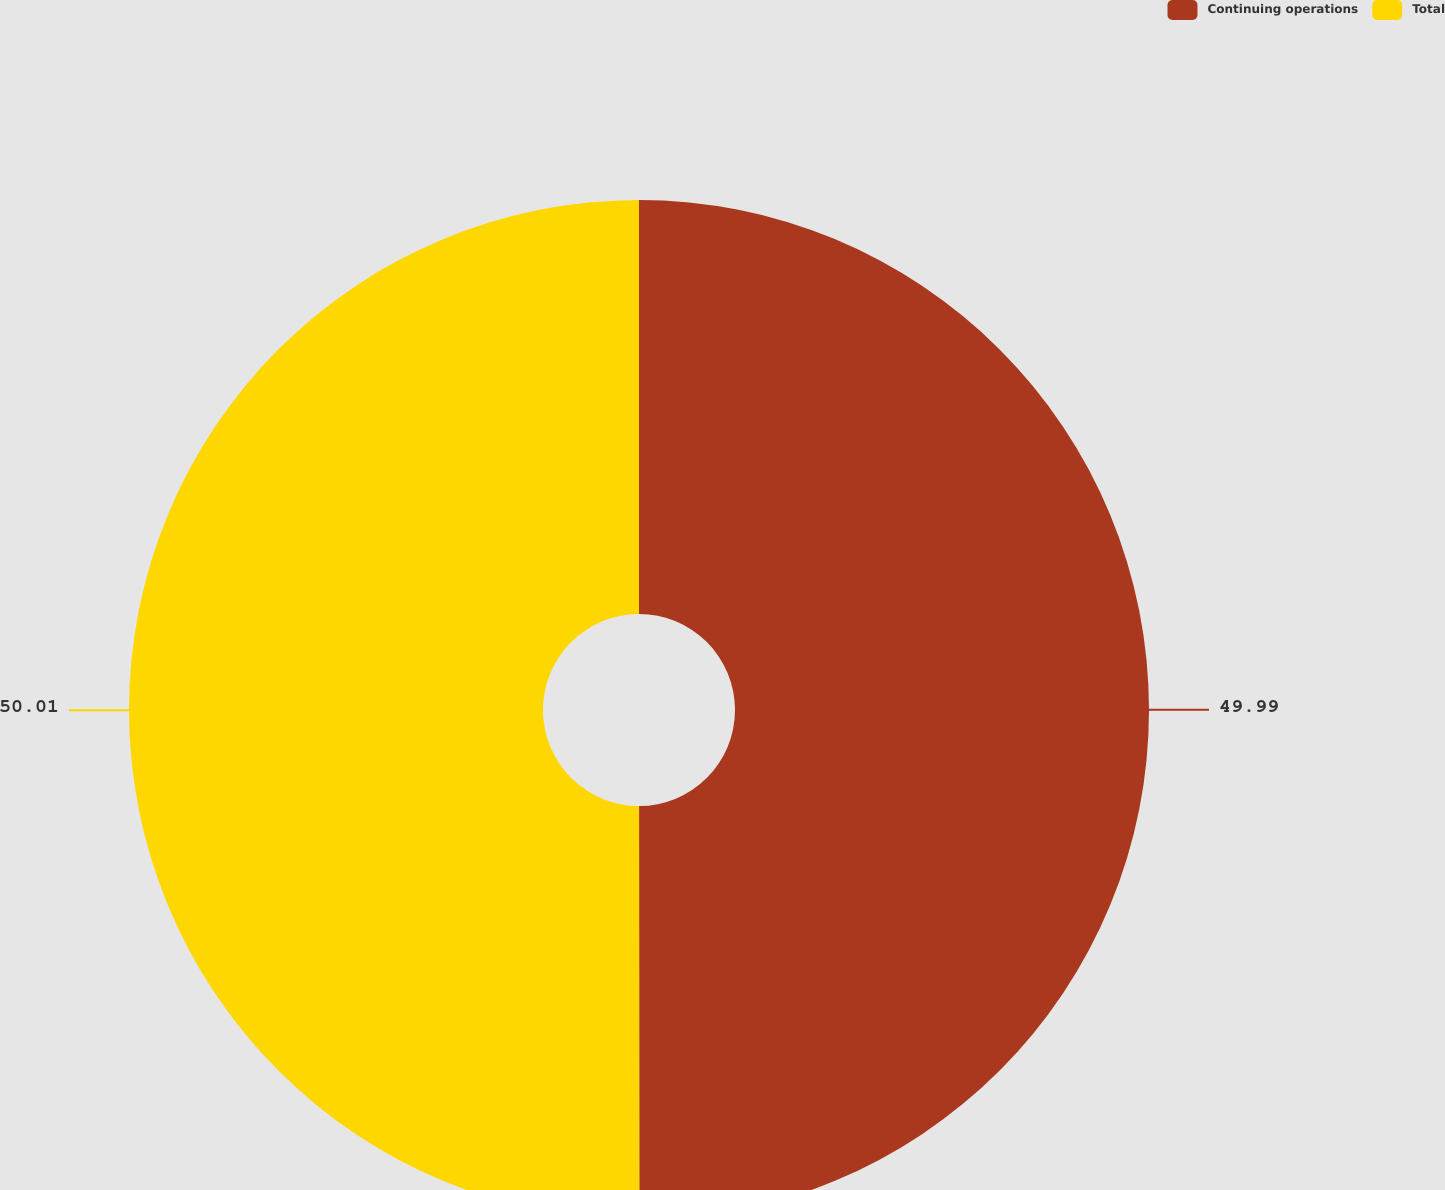Convert chart. <chart><loc_0><loc_0><loc_500><loc_500><pie_chart><fcel>Continuing operations<fcel>Total<nl><fcel>49.99%<fcel>50.01%<nl></chart> 